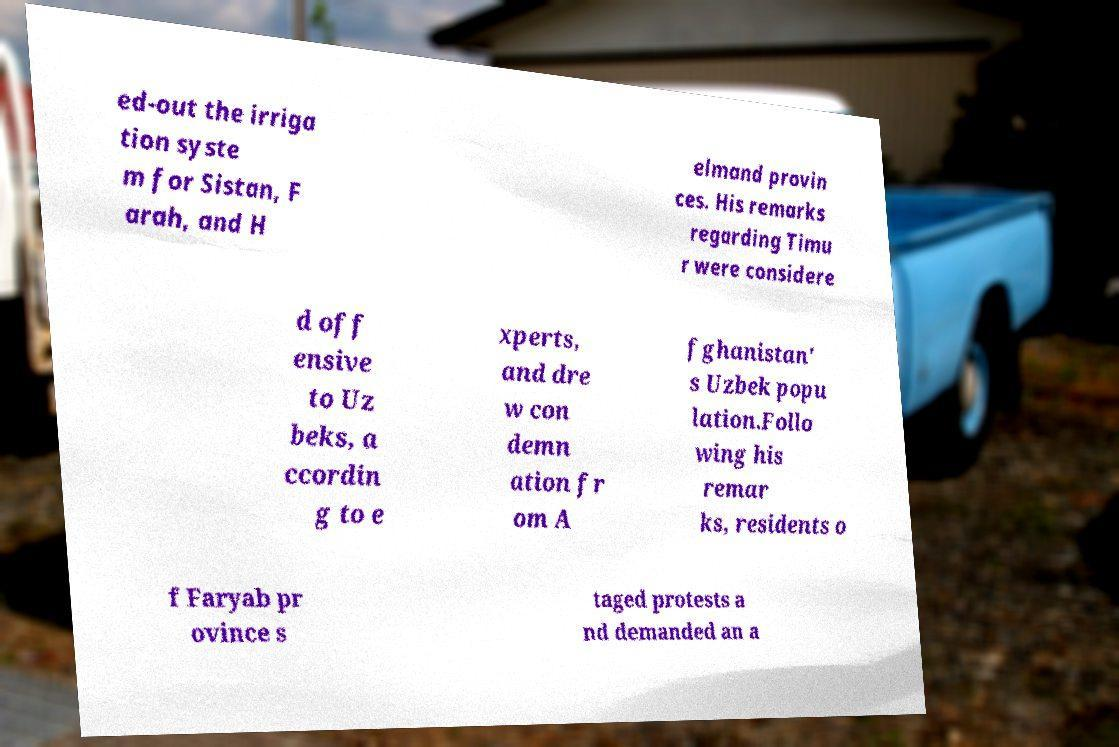What messages or text are displayed in this image? I need them in a readable, typed format. ed-out the irriga tion syste m for Sistan, F arah, and H elmand provin ces. His remarks regarding Timu r were considere d off ensive to Uz beks, a ccordin g to e xperts, and dre w con demn ation fr om A fghanistan' s Uzbek popu lation.Follo wing his remar ks, residents o f Faryab pr ovince s taged protests a nd demanded an a 